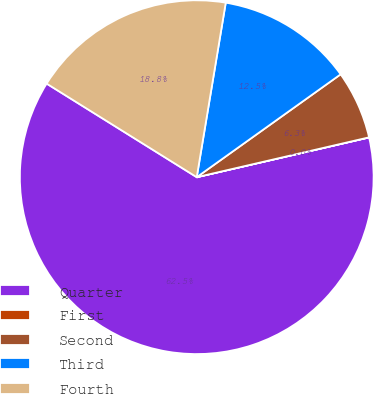<chart> <loc_0><loc_0><loc_500><loc_500><pie_chart><fcel>Quarter<fcel>First<fcel>Second<fcel>Third<fcel>Fourth<nl><fcel>62.48%<fcel>0.01%<fcel>6.26%<fcel>12.5%<fcel>18.75%<nl></chart> 